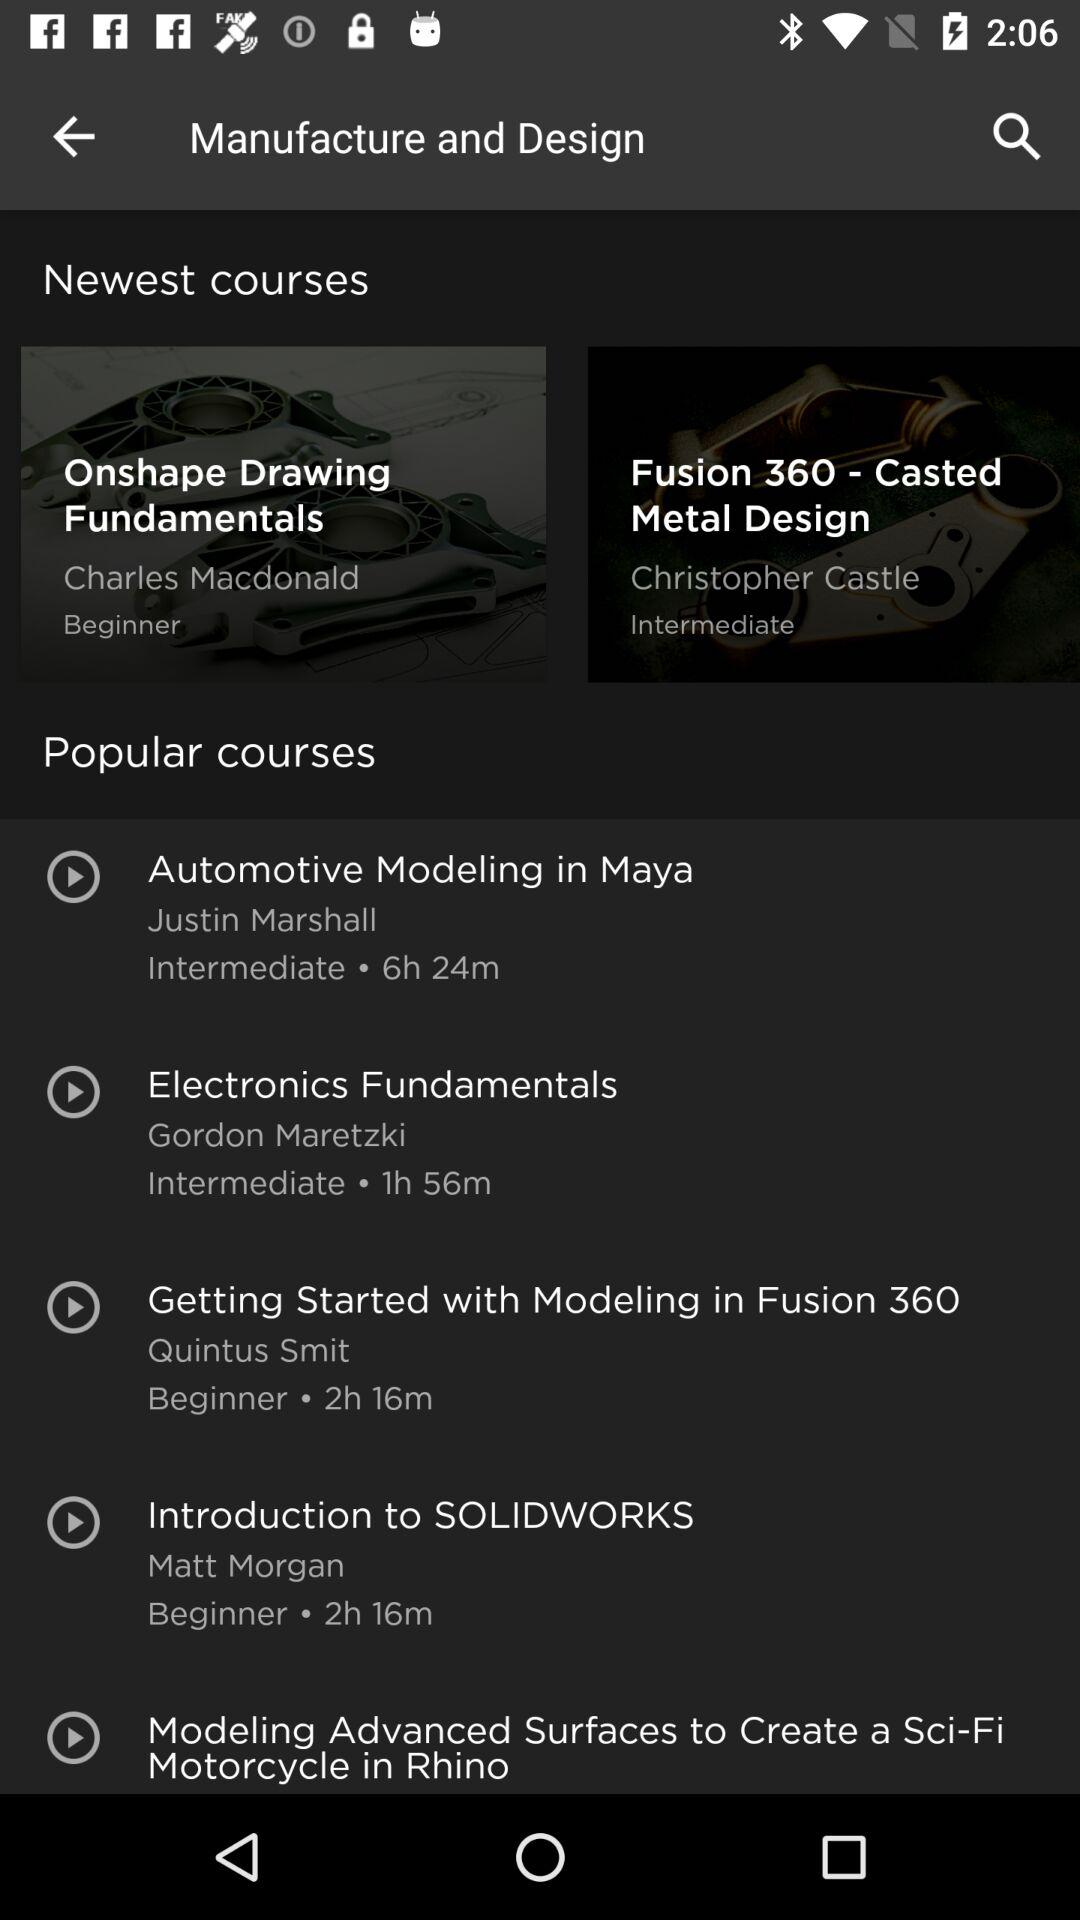What is the name of the newest course by Charles Macdonald? The name of the newest course by Charles Macdonald is "Onshape Drawing Fundamentals". 